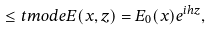Convert formula to latex. <formula><loc_0><loc_0><loc_500><loc_500>\leq t { m o d e } E ( x , z ) = E _ { 0 } ( x ) e ^ { i h z } ,</formula> 